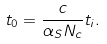<formula> <loc_0><loc_0><loc_500><loc_500>t _ { 0 } = \frac { c } { \alpha _ { S } N _ { c } } t _ { i } .</formula> 